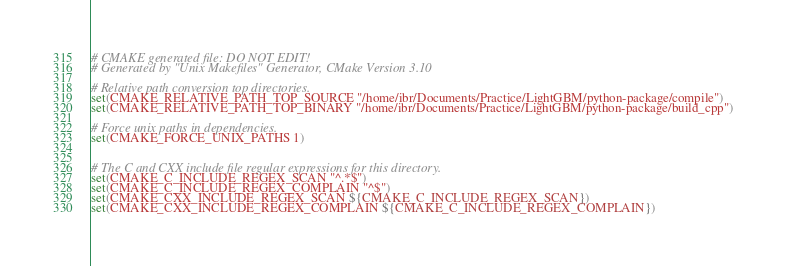<code> <loc_0><loc_0><loc_500><loc_500><_CMake_># CMAKE generated file: DO NOT EDIT!
# Generated by "Unix Makefiles" Generator, CMake Version 3.10

# Relative path conversion top directories.
set(CMAKE_RELATIVE_PATH_TOP_SOURCE "/home/ibr/Documents/Practice/LightGBM/python-package/compile")
set(CMAKE_RELATIVE_PATH_TOP_BINARY "/home/ibr/Documents/Practice/LightGBM/python-package/build_cpp")

# Force unix paths in dependencies.
set(CMAKE_FORCE_UNIX_PATHS 1)


# The C and CXX include file regular expressions for this directory.
set(CMAKE_C_INCLUDE_REGEX_SCAN "^.*$")
set(CMAKE_C_INCLUDE_REGEX_COMPLAIN "^$")
set(CMAKE_CXX_INCLUDE_REGEX_SCAN ${CMAKE_C_INCLUDE_REGEX_SCAN})
set(CMAKE_CXX_INCLUDE_REGEX_COMPLAIN ${CMAKE_C_INCLUDE_REGEX_COMPLAIN})
</code> 